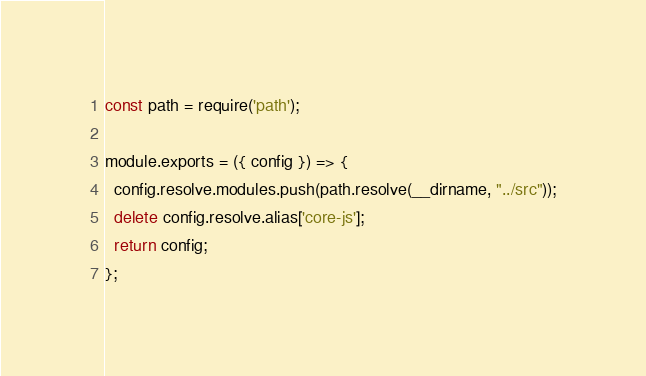Convert code to text. <code><loc_0><loc_0><loc_500><loc_500><_JavaScript_>const path = require('path');

module.exports = ({ config }) => {
  config.resolve.modules.push(path.resolve(__dirname, "../src"));
  delete config.resolve.alias['core-js'];
  return config;
};
</code> 